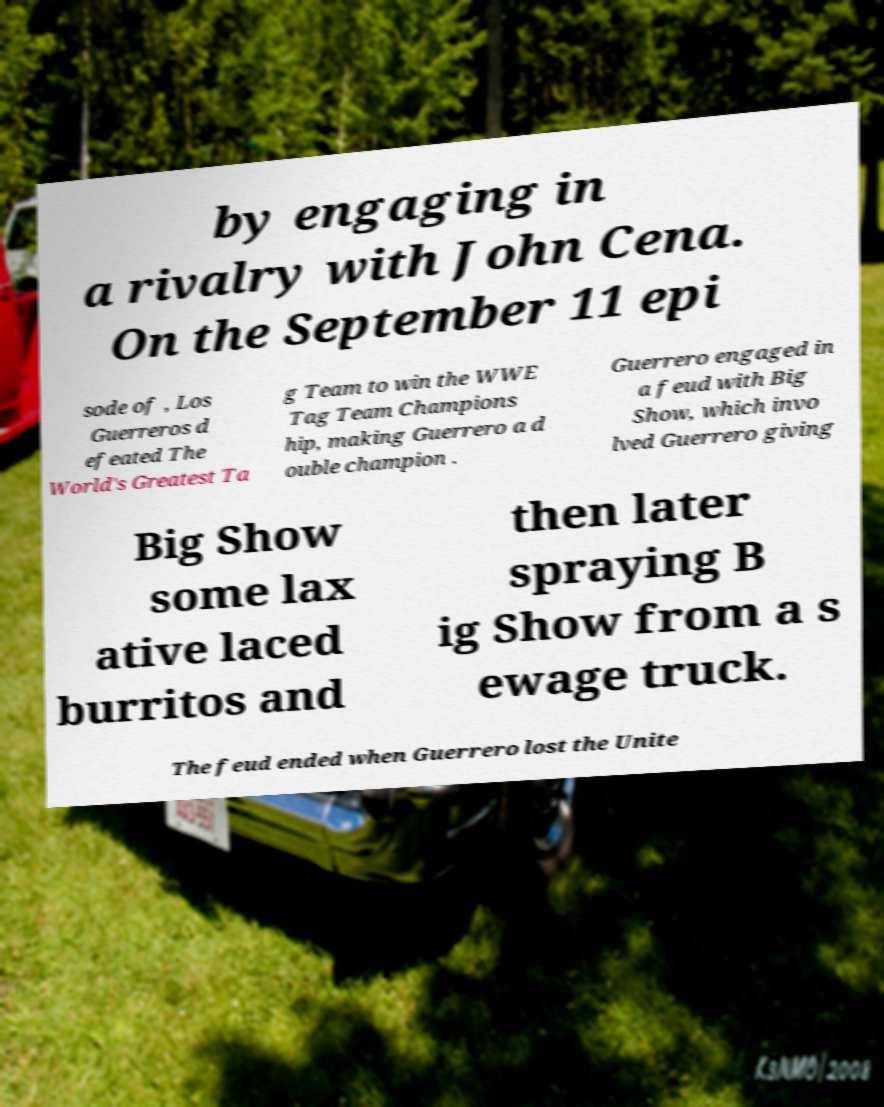Can you accurately transcribe the text from the provided image for me? by engaging in a rivalry with John Cena. On the September 11 epi sode of , Los Guerreros d efeated The World's Greatest Ta g Team to win the WWE Tag Team Champions hip, making Guerrero a d ouble champion . Guerrero engaged in a feud with Big Show, which invo lved Guerrero giving Big Show some lax ative laced burritos and then later spraying B ig Show from a s ewage truck. The feud ended when Guerrero lost the Unite 